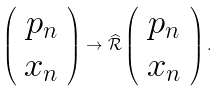<formula> <loc_0><loc_0><loc_500><loc_500>\left ( \begin{array} { c } p _ { n } \\ x _ { n } \end{array} \right ) \to \widehat { \mathcal { R } } \left ( \begin{array} { c } p _ { n } \\ x _ { n } \end{array} \right ) .</formula> 